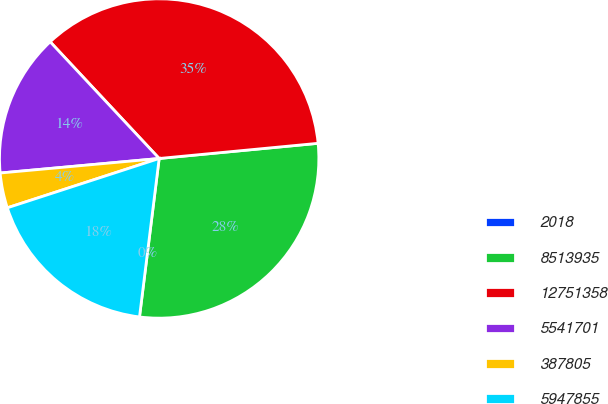Convert chart to OTSL. <chart><loc_0><loc_0><loc_500><loc_500><pie_chart><fcel>2018<fcel>8513935<fcel>12751358<fcel>5541701<fcel>387805<fcel>5947855<nl><fcel>0.0%<fcel>28.48%<fcel>35.44%<fcel>14.49%<fcel>3.55%<fcel>18.03%<nl></chart> 